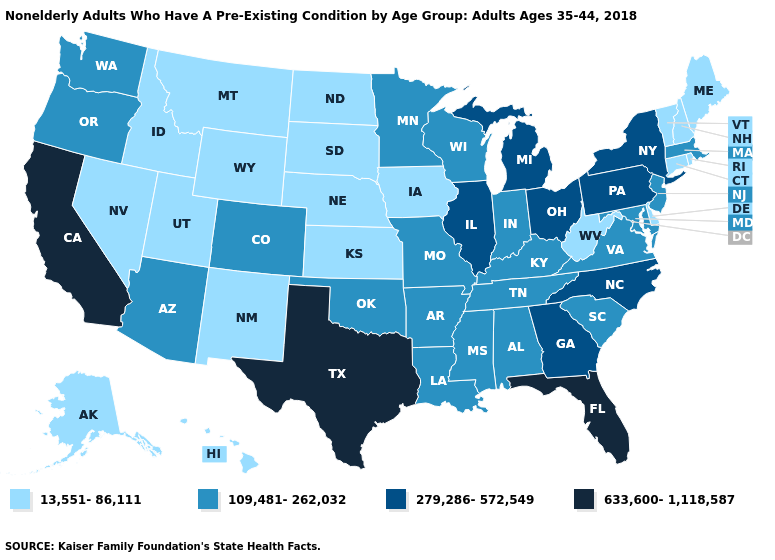Does Pennsylvania have the highest value in the Northeast?
Be succinct. Yes. Does Oregon have the lowest value in the West?
Give a very brief answer. No. Name the states that have a value in the range 633,600-1,118,587?
Be succinct. California, Florida, Texas. Does Arizona have a higher value than Mississippi?
Keep it brief. No. Name the states that have a value in the range 13,551-86,111?
Quick response, please. Alaska, Connecticut, Delaware, Hawaii, Idaho, Iowa, Kansas, Maine, Montana, Nebraska, Nevada, New Hampshire, New Mexico, North Dakota, Rhode Island, South Dakota, Utah, Vermont, West Virginia, Wyoming. What is the value of Washington?
Quick response, please. 109,481-262,032. Which states hav the highest value in the MidWest?
Quick response, please. Illinois, Michigan, Ohio. What is the lowest value in the MidWest?
Short answer required. 13,551-86,111. Does Florida have the highest value in the USA?
Keep it brief. Yes. Among the states that border West Virginia , which have the highest value?
Be succinct. Ohio, Pennsylvania. Name the states that have a value in the range 633,600-1,118,587?
Write a very short answer. California, Florida, Texas. What is the highest value in the MidWest ?
Answer briefly. 279,286-572,549. Name the states that have a value in the range 279,286-572,549?
Short answer required. Georgia, Illinois, Michigan, New York, North Carolina, Ohio, Pennsylvania. Among the states that border North Carolina , does Virginia have the lowest value?
Quick response, please. Yes. Does California have the highest value in the USA?
Be succinct. Yes. 